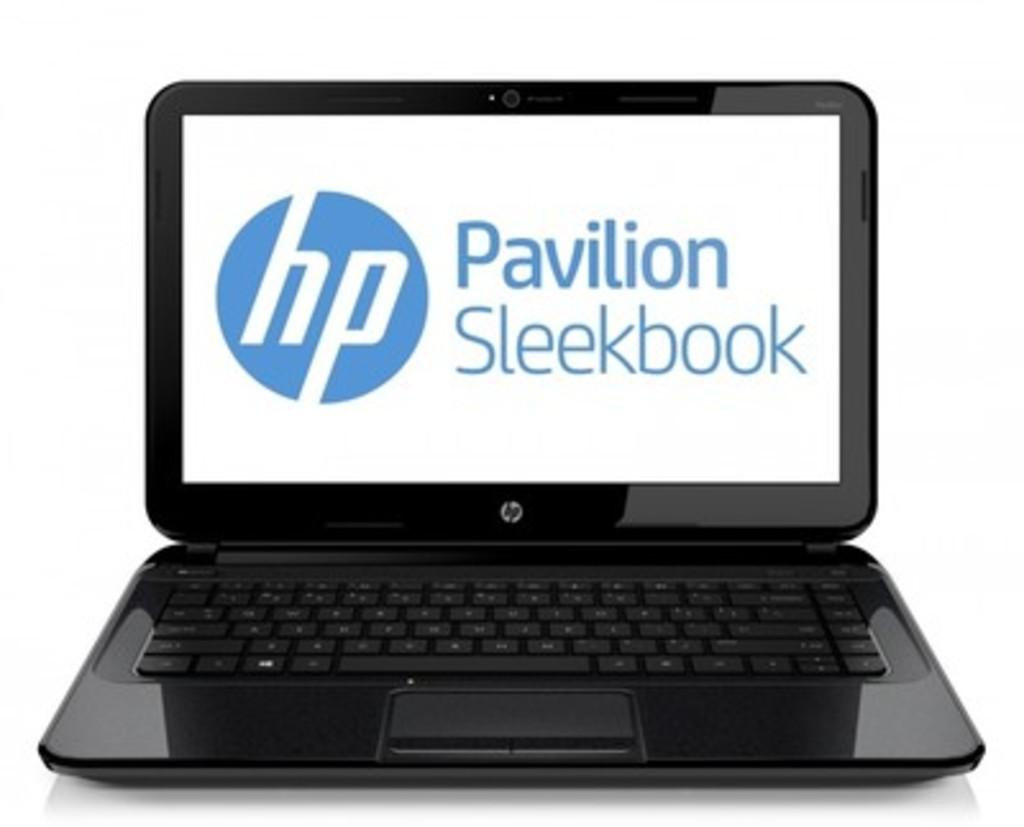Provide a one-sentence caption for the provided image. a laptop computer the brand is hp pavilion. 